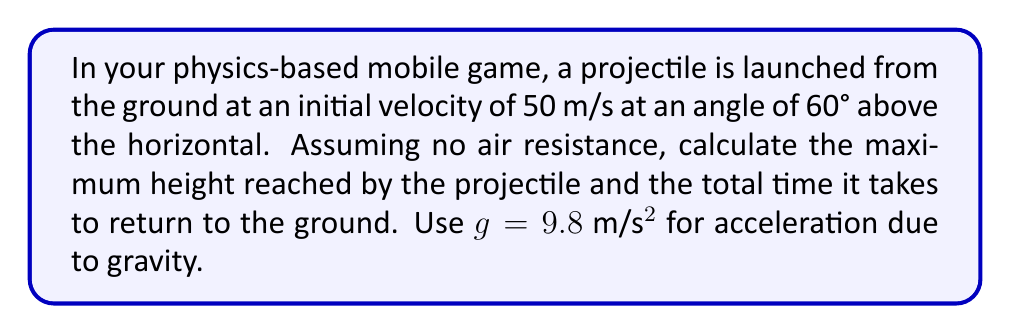Solve this math problem. Let's break this down step-by-step:

1) First, we need to decompose the initial velocity into its vertical and horizontal components:

   $v_{0x} = v_0 \cos\theta = 50 \cos(60°) = 25$ m/s
   $v_{0y} = v_0 \sin\theta = 50 \sin(60°) = 43.3$ m/s

2) To find the maximum height, we use the equation:

   $y_{max} = \frac{v_{0y}^2}{2g}$

   Substituting our values:
   $y_{max} = \frac{(43.3)^2}{2(9.8)} = 95.7$ m

3) To find the total time of flight, we need to calculate the time to reach the maximum height and double it:

   Time to reach max height: $t_{up} = \frac{v_{0y}}{g} = \frac{43.3}{9.8} = 4.42$ s

   Total time: $t_{total} = 2t_{up} = 2(4.42) = 8.84$ s

We can verify this using the quadratic equation for position:

$y = y_0 + v_{0y}t - \frac{1}{2}gt^2$

At the ground, $y = 0$, $y_0 = 0$, so:

$0 = 43.3t - 4.9t^2$

Solving this quadratic equation confirms our total time of 8.84 seconds.
Answer: Maximum height: 95.7 m
Total time: 8.84 s 